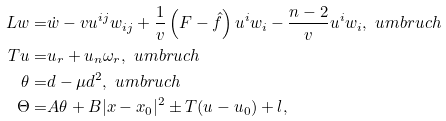Convert formula to latex. <formula><loc_0><loc_0><loc_500><loc_500>L w = & \dot { w } - v u ^ { i j } w _ { i j } + \frac { 1 } { v } \left ( F - \hat { f } \right ) u ^ { i } w _ { i } - \frac { n - 2 } v u ^ { i } w _ { i } , \ u m b r u c h \\ T u = & u _ { r } + u _ { n } \omega _ { r } , \ u m b r u c h \\ \theta = & d - \mu d ^ { 2 } , \ u m b r u c h \\ \Theta = & A \theta + B | x - x _ { 0 } | ^ { 2 } \pm T ( u - u _ { 0 } ) + l ,</formula> 